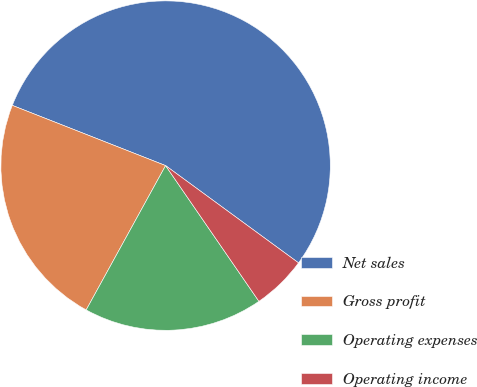Convert chart. <chart><loc_0><loc_0><loc_500><loc_500><pie_chart><fcel>Net sales<fcel>Gross profit<fcel>Operating expenses<fcel>Operating income<nl><fcel>54.09%<fcel>22.95%<fcel>17.59%<fcel>5.36%<nl></chart> 